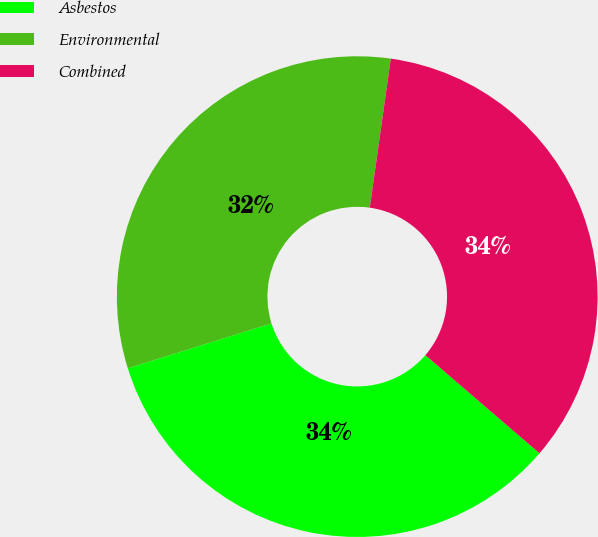Convert chart. <chart><loc_0><loc_0><loc_500><loc_500><pie_chart><fcel>Asbestos<fcel>Environmental<fcel>Combined<nl><fcel>33.88%<fcel>32.05%<fcel>34.07%<nl></chart> 